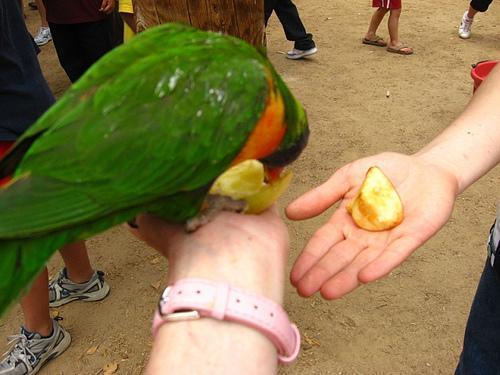How many birds?
Give a very brief answer. 1. How many people are there?
Give a very brief answer. 4. 